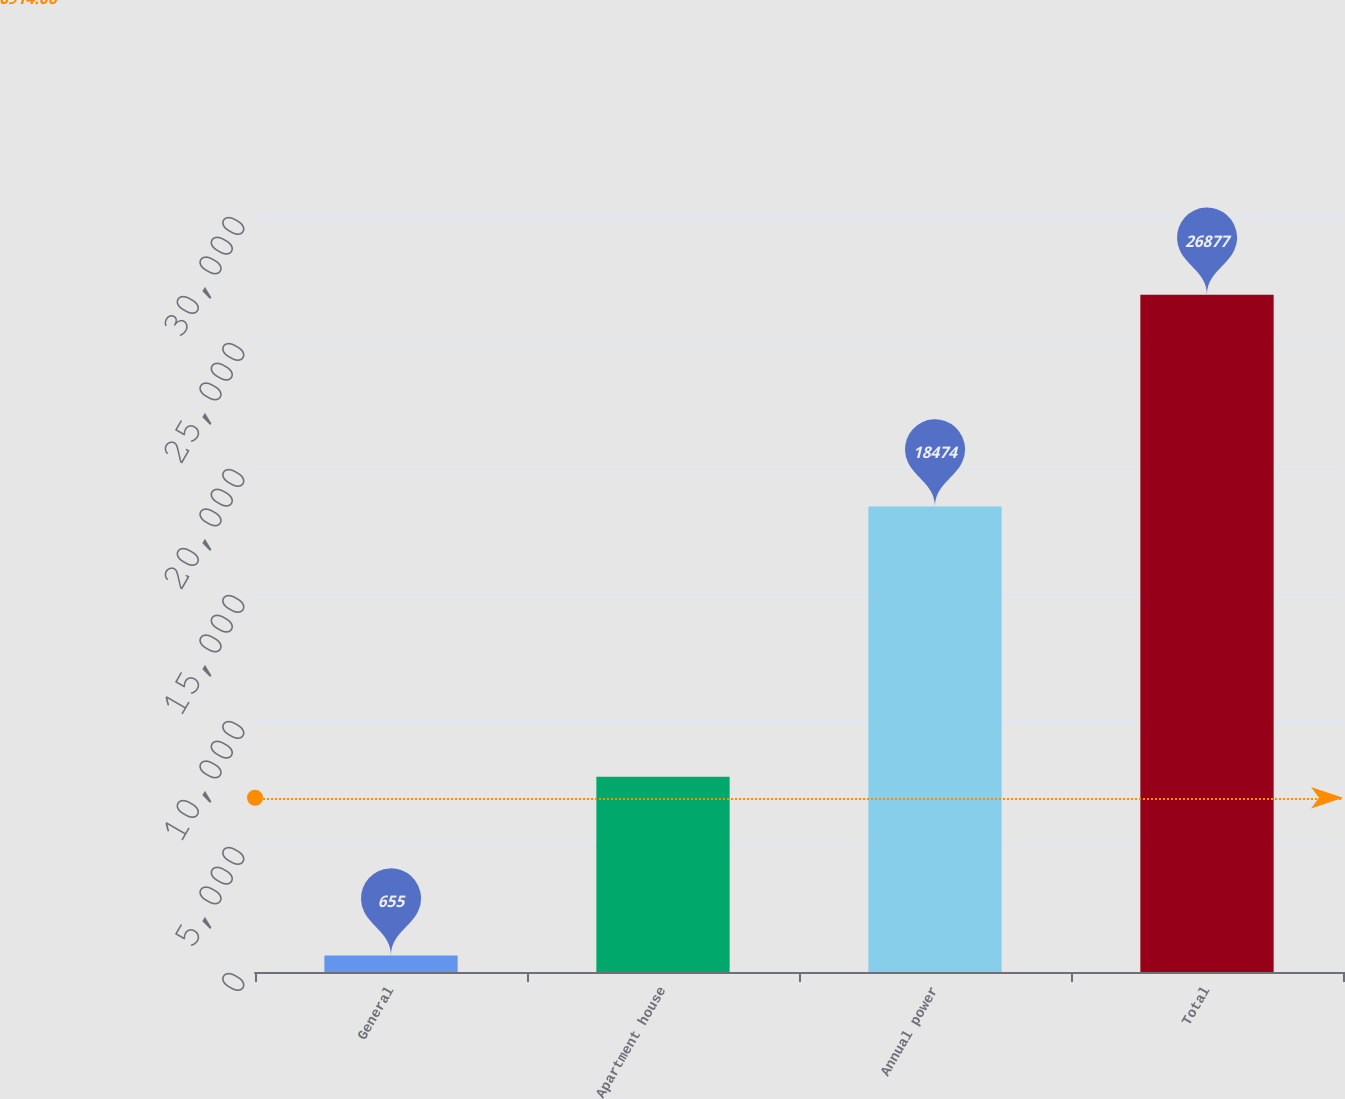<chart> <loc_0><loc_0><loc_500><loc_500><bar_chart><fcel>General<fcel>Apartment house<fcel>Annual power<fcel>Total<nl><fcel>655<fcel>7748<fcel>18474<fcel>26877<nl></chart> 